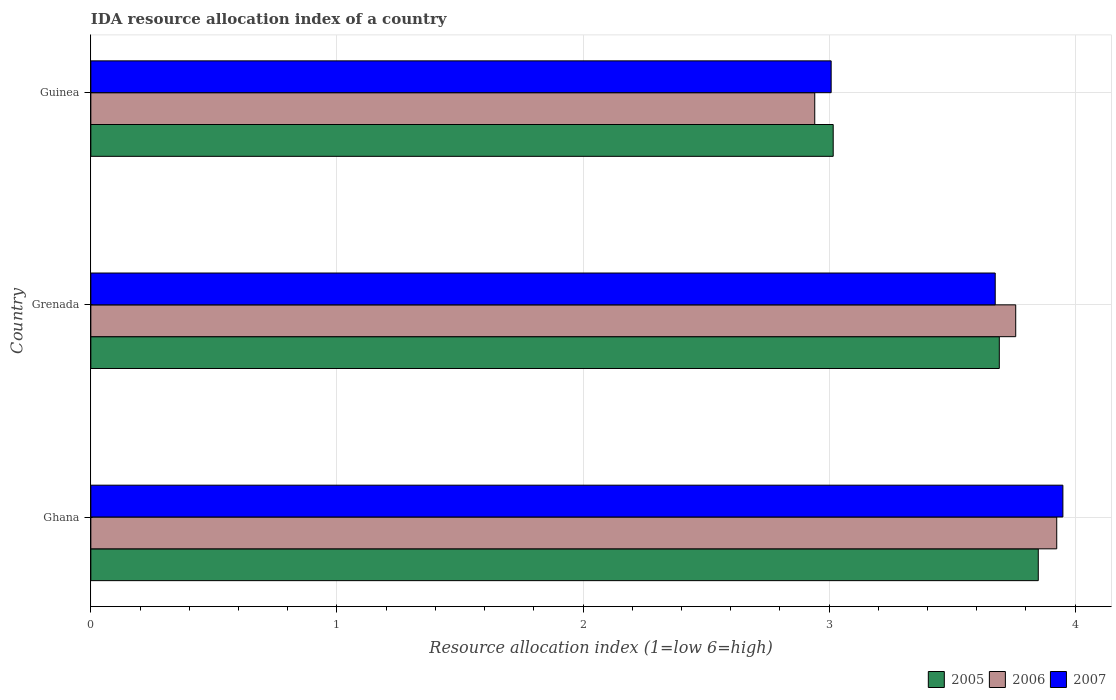How many groups of bars are there?
Provide a short and direct response. 3. Are the number of bars per tick equal to the number of legend labels?
Your response must be concise. Yes. How many bars are there on the 1st tick from the top?
Make the answer very short. 3. How many bars are there on the 2nd tick from the bottom?
Provide a succinct answer. 3. In how many cases, is the number of bars for a given country not equal to the number of legend labels?
Offer a terse response. 0. What is the IDA resource allocation index in 2005 in Grenada?
Keep it short and to the point. 3.69. Across all countries, what is the maximum IDA resource allocation index in 2007?
Provide a succinct answer. 3.95. Across all countries, what is the minimum IDA resource allocation index in 2006?
Ensure brevity in your answer.  2.94. In which country was the IDA resource allocation index in 2005 maximum?
Ensure brevity in your answer.  Ghana. In which country was the IDA resource allocation index in 2005 minimum?
Your response must be concise. Guinea. What is the total IDA resource allocation index in 2005 in the graph?
Your response must be concise. 10.56. What is the difference between the IDA resource allocation index in 2005 in Grenada and that in Guinea?
Your answer should be very brief. 0.67. What is the difference between the IDA resource allocation index in 2006 in Grenada and the IDA resource allocation index in 2007 in Ghana?
Provide a succinct answer. -0.19. What is the average IDA resource allocation index in 2007 per country?
Ensure brevity in your answer.  3.54. What is the difference between the IDA resource allocation index in 2007 and IDA resource allocation index in 2005 in Guinea?
Provide a short and direct response. -0.01. What is the ratio of the IDA resource allocation index in 2005 in Ghana to that in Guinea?
Provide a short and direct response. 1.28. What is the difference between the highest and the second highest IDA resource allocation index in 2005?
Keep it short and to the point. 0.16. What is the difference between the highest and the lowest IDA resource allocation index in 2005?
Your answer should be compact. 0.83. Is the sum of the IDA resource allocation index in 2006 in Ghana and Guinea greater than the maximum IDA resource allocation index in 2007 across all countries?
Provide a short and direct response. Yes. What does the 2nd bar from the top in Ghana represents?
Your answer should be very brief. 2006. What is the difference between two consecutive major ticks on the X-axis?
Your response must be concise. 1. Are the values on the major ticks of X-axis written in scientific E-notation?
Your response must be concise. No. Does the graph contain any zero values?
Offer a terse response. No. Does the graph contain grids?
Your answer should be compact. Yes. How many legend labels are there?
Make the answer very short. 3. How are the legend labels stacked?
Give a very brief answer. Horizontal. What is the title of the graph?
Provide a short and direct response. IDA resource allocation index of a country. Does "1992" appear as one of the legend labels in the graph?
Offer a very short reply. No. What is the label or title of the X-axis?
Make the answer very short. Resource allocation index (1=low 6=high). What is the Resource allocation index (1=low 6=high) of 2005 in Ghana?
Provide a succinct answer. 3.85. What is the Resource allocation index (1=low 6=high) of 2006 in Ghana?
Offer a terse response. 3.92. What is the Resource allocation index (1=low 6=high) of 2007 in Ghana?
Provide a short and direct response. 3.95. What is the Resource allocation index (1=low 6=high) in 2005 in Grenada?
Provide a short and direct response. 3.69. What is the Resource allocation index (1=low 6=high) in 2006 in Grenada?
Give a very brief answer. 3.76. What is the Resource allocation index (1=low 6=high) in 2007 in Grenada?
Offer a terse response. 3.67. What is the Resource allocation index (1=low 6=high) of 2005 in Guinea?
Ensure brevity in your answer.  3.02. What is the Resource allocation index (1=low 6=high) in 2006 in Guinea?
Offer a terse response. 2.94. What is the Resource allocation index (1=low 6=high) of 2007 in Guinea?
Make the answer very short. 3.01. Across all countries, what is the maximum Resource allocation index (1=low 6=high) of 2005?
Offer a very short reply. 3.85. Across all countries, what is the maximum Resource allocation index (1=low 6=high) in 2006?
Your response must be concise. 3.92. Across all countries, what is the maximum Resource allocation index (1=low 6=high) of 2007?
Your response must be concise. 3.95. Across all countries, what is the minimum Resource allocation index (1=low 6=high) of 2005?
Provide a succinct answer. 3.02. Across all countries, what is the minimum Resource allocation index (1=low 6=high) in 2006?
Ensure brevity in your answer.  2.94. Across all countries, what is the minimum Resource allocation index (1=low 6=high) in 2007?
Keep it short and to the point. 3.01. What is the total Resource allocation index (1=low 6=high) of 2005 in the graph?
Your answer should be compact. 10.56. What is the total Resource allocation index (1=low 6=high) of 2006 in the graph?
Your response must be concise. 10.62. What is the total Resource allocation index (1=low 6=high) in 2007 in the graph?
Offer a very short reply. 10.63. What is the difference between the Resource allocation index (1=low 6=high) in 2005 in Ghana and that in Grenada?
Keep it short and to the point. 0.16. What is the difference between the Resource allocation index (1=low 6=high) in 2006 in Ghana and that in Grenada?
Give a very brief answer. 0.17. What is the difference between the Resource allocation index (1=low 6=high) of 2007 in Ghana and that in Grenada?
Give a very brief answer. 0.28. What is the difference between the Resource allocation index (1=low 6=high) in 2006 in Ghana and that in Guinea?
Give a very brief answer. 0.98. What is the difference between the Resource allocation index (1=low 6=high) in 2007 in Ghana and that in Guinea?
Keep it short and to the point. 0.94. What is the difference between the Resource allocation index (1=low 6=high) of 2005 in Grenada and that in Guinea?
Your response must be concise. 0.68. What is the difference between the Resource allocation index (1=low 6=high) in 2006 in Grenada and that in Guinea?
Keep it short and to the point. 0.82. What is the difference between the Resource allocation index (1=low 6=high) of 2007 in Grenada and that in Guinea?
Your response must be concise. 0.67. What is the difference between the Resource allocation index (1=low 6=high) in 2005 in Ghana and the Resource allocation index (1=low 6=high) in 2006 in Grenada?
Your answer should be very brief. 0.09. What is the difference between the Resource allocation index (1=low 6=high) of 2005 in Ghana and the Resource allocation index (1=low 6=high) of 2007 in Grenada?
Offer a very short reply. 0.17. What is the difference between the Resource allocation index (1=low 6=high) of 2005 in Ghana and the Resource allocation index (1=low 6=high) of 2006 in Guinea?
Offer a very short reply. 0.91. What is the difference between the Resource allocation index (1=low 6=high) in 2005 in Ghana and the Resource allocation index (1=low 6=high) in 2007 in Guinea?
Your response must be concise. 0.84. What is the difference between the Resource allocation index (1=low 6=high) in 2005 in Grenada and the Resource allocation index (1=low 6=high) in 2006 in Guinea?
Give a very brief answer. 0.75. What is the difference between the Resource allocation index (1=low 6=high) in 2005 in Grenada and the Resource allocation index (1=low 6=high) in 2007 in Guinea?
Provide a short and direct response. 0.68. What is the difference between the Resource allocation index (1=low 6=high) of 2006 in Grenada and the Resource allocation index (1=low 6=high) of 2007 in Guinea?
Provide a succinct answer. 0.75. What is the average Resource allocation index (1=low 6=high) in 2005 per country?
Your answer should be compact. 3.52. What is the average Resource allocation index (1=low 6=high) in 2006 per country?
Offer a very short reply. 3.54. What is the average Resource allocation index (1=low 6=high) in 2007 per country?
Offer a terse response. 3.54. What is the difference between the Resource allocation index (1=low 6=high) of 2005 and Resource allocation index (1=low 6=high) of 2006 in Ghana?
Your answer should be very brief. -0.07. What is the difference between the Resource allocation index (1=low 6=high) of 2006 and Resource allocation index (1=low 6=high) of 2007 in Ghana?
Offer a very short reply. -0.03. What is the difference between the Resource allocation index (1=low 6=high) of 2005 and Resource allocation index (1=low 6=high) of 2006 in Grenada?
Provide a short and direct response. -0.07. What is the difference between the Resource allocation index (1=low 6=high) of 2005 and Resource allocation index (1=low 6=high) of 2007 in Grenada?
Your answer should be compact. 0.02. What is the difference between the Resource allocation index (1=low 6=high) in 2006 and Resource allocation index (1=low 6=high) in 2007 in Grenada?
Your response must be concise. 0.08. What is the difference between the Resource allocation index (1=low 6=high) in 2005 and Resource allocation index (1=low 6=high) in 2006 in Guinea?
Ensure brevity in your answer.  0.07. What is the difference between the Resource allocation index (1=low 6=high) of 2005 and Resource allocation index (1=low 6=high) of 2007 in Guinea?
Give a very brief answer. 0.01. What is the difference between the Resource allocation index (1=low 6=high) in 2006 and Resource allocation index (1=low 6=high) in 2007 in Guinea?
Your answer should be compact. -0.07. What is the ratio of the Resource allocation index (1=low 6=high) in 2005 in Ghana to that in Grenada?
Ensure brevity in your answer.  1.04. What is the ratio of the Resource allocation index (1=low 6=high) in 2006 in Ghana to that in Grenada?
Provide a succinct answer. 1.04. What is the ratio of the Resource allocation index (1=low 6=high) of 2007 in Ghana to that in Grenada?
Provide a short and direct response. 1.07. What is the ratio of the Resource allocation index (1=low 6=high) of 2005 in Ghana to that in Guinea?
Provide a short and direct response. 1.28. What is the ratio of the Resource allocation index (1=low 6=high) of 2006 in Ghana to that in Guinea?
Your answer should be compact. 1.33. What is the ratio of the Resource allocation index (1=low 6=high) of 2007 in Ghana to that in Guinea?
Keep it short and to the point. 1.31. What is the ratio of the Resource allocation index (1=low 6=high) of 2005 in Grenada to that in Guinea?
Ensure brevity in your answer.  1.22. What is the ratio of the Resource allocation index (1=low 6=high) in 2006 in Grenada to that in Guinea?
Your response must be concise. 1.28. What is the ratio of the Resource allocation index (1=low 6=high) of 2007 in Grenada to that in Guinea?
Your answer should be compact. 1.22. What is the difference between the highest and the second highest Resource allocation index (1=low 6=high) of 2005?
Provide a succinct answer. 0.16. What is the difference between the highest and the second highest Resource allocation index (1=low 6=high) of 2007?
Ensure brevity in your answer.  0.28. What is the difference between the highest and the lowest Resource allocation index (1=low 6=high) in 2006?
Your response must be concise. 0.98. What is the difference between the highest and the lowest Resource allocation index (1=low 6=high) in 2007?
Your answer should be compact. 0.94. 